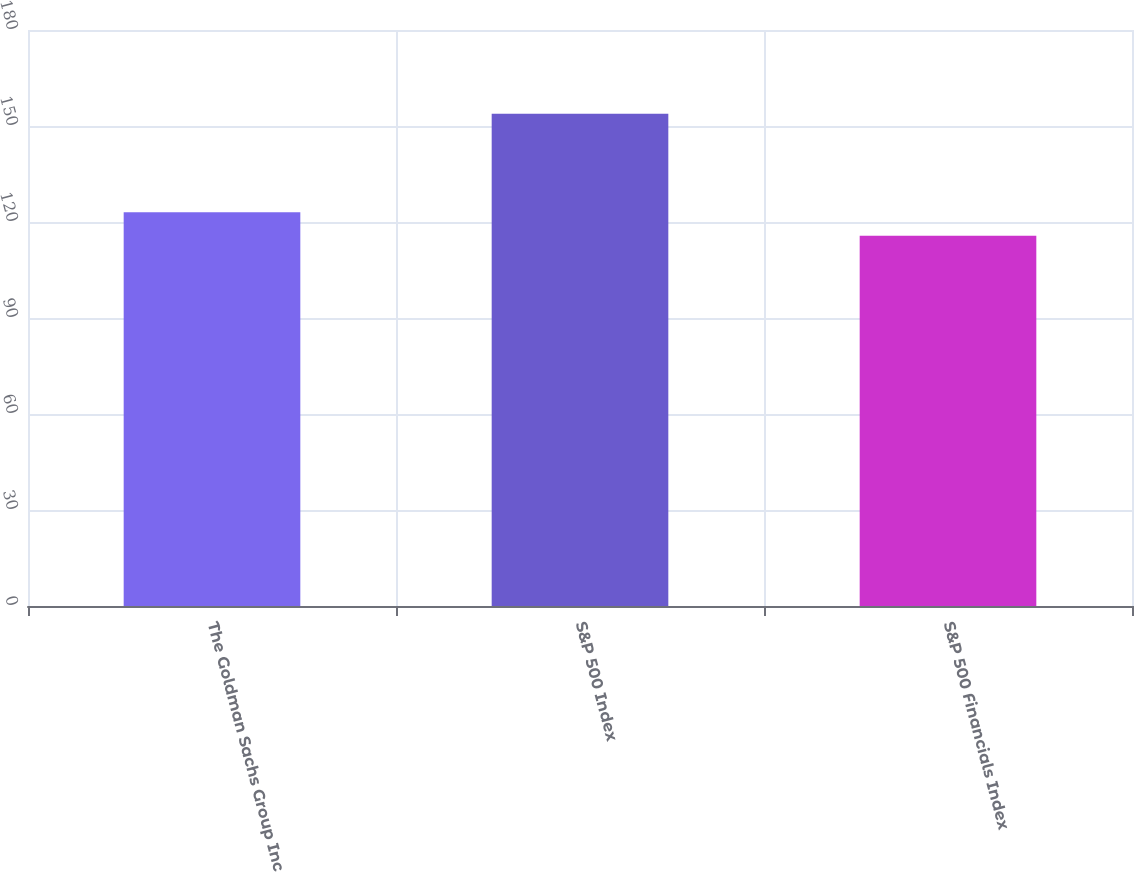Convert chart. <chart><loc_0><loc_0><loc_500><loc_500><bar_chart><fcel>The Goldman Sachs Group Inc<fcel>S&P 500 Index<fcel>S&P 500 Financials Index<nl><fcel>123.05<fcel>153.83<fcel>115.67<nl></chart> 